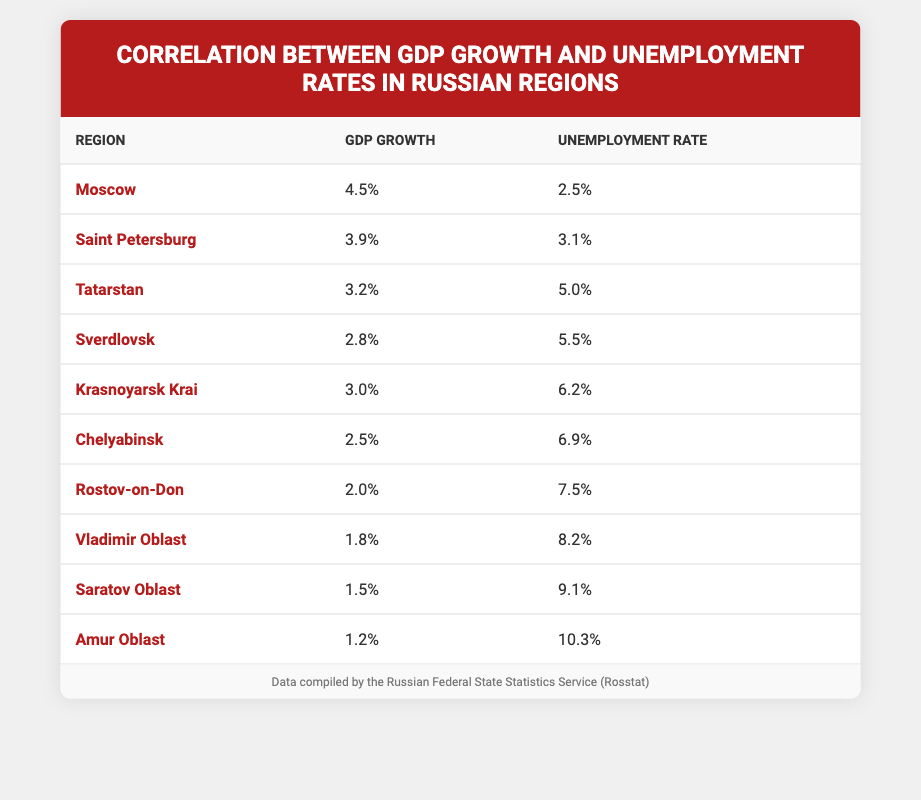What's the GDP growth for Rostov-on-Don? The table directly lists the GDP growth for Rostov-on-Don at 2.0.
Answer: 2.0 Which region has the highest unemployment rate? By comparing the unemployment rates listed in the table, Amur Oblast has the highest unemployment rate at 10.3.
Answer: Amur Oblast What is the difference in GDP growth between Moscow and Saratov Oblast? The GDP growth for Moscow is 4.5 and for Saratov Oblast is 1.5. The difference is 4.5 - 1.5 = 3.0.
Answer: 3.0 Is the unemployment rate in Tatarstan higher than that in Moscow? Tatarstan's unemployment rate is 5.0 and Moscow's is 2.5. Since 5.0 is greater than 2.5, this statement is true.
Answer: Yes What is the average GDP growth of the regions listed? To find the average, sum all GDP growth values (4.5 + 3.9 + 3.2 + 2.8 + 3.0 + 2.5 + 2.0 + 1.8 + 1.5 + 1.2 = 25.6) and divide by the number of regions (10). Thus, the average is 25.6 / 10 = 2.56.
Answer: 2.56 Which region has the lowest GDP growth, and what is that value? By examining all GDP growth values, the lowest is 1.2 associated with Amur Oblast.
Answer: Amur Oblast, 1.2 Is there a direct correlation between higher GDP growth and lower unemployment rates in the table? The data suggests that regions with higher GDP growth generally have lower unemployment rates; for example, Moscow and Amur Oblast illustrate this trend. However, while this correlation seems evident, further statistical analysis would be needed to confirm it.
Answer: Yes What is the total unemployment rate for the regions listed? The total unemployment rate is calculated by summing all the unemployment rates (2.5 + 3.1 + 5.0 + 5.5 + 6.2 + 6.9 + 7.5 + 8.2 + 9.1 + 10.3 = 54.9).
Answer: 54.9 What is the unemployment rate of the region with the second highest GDP growth? The region with the second highest GDP growth is Saint Petersburg (3.9). Looking at the unemployment rates, Saint Petersburg has an unemployment rate of 3.1.
Answer: 3.1 